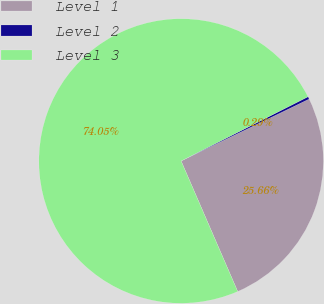Convert chart to OTSL. <chart><loc_0><loc_0><loc_500><loc_500><pie_chart><fcel>Level 1<fcel>Level 2<fcel>Level 3<nl><fcel>25.66%<fcel>0.29%<fcel>74.05%<nl></chart> 